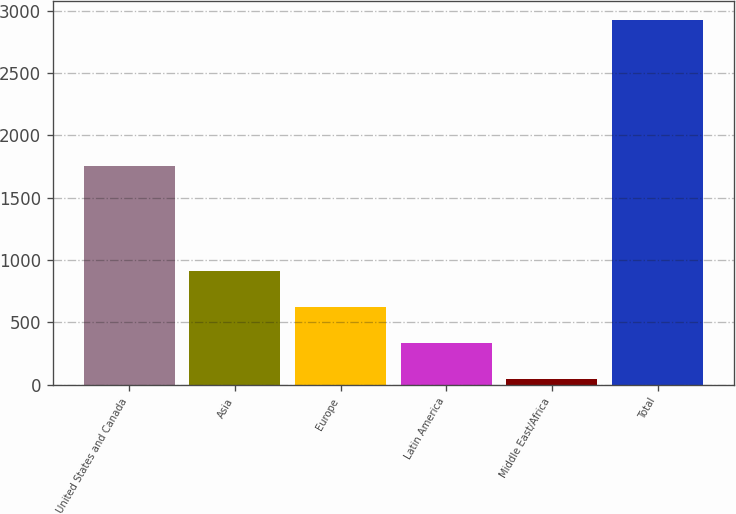<chart> <loc_0><loc_0><loc_500><loc_500><bar_chart><fcel>United States and Canada<fcel>Asia<fcel>Europe<fcel>Latin America<fcel>Middle East/Africa<fcel>Total<nl><fcel>1756<fcel>913.7<fcel>625.8<fcel>337.9<fcel>50<fcel>2929<nl></chart> 